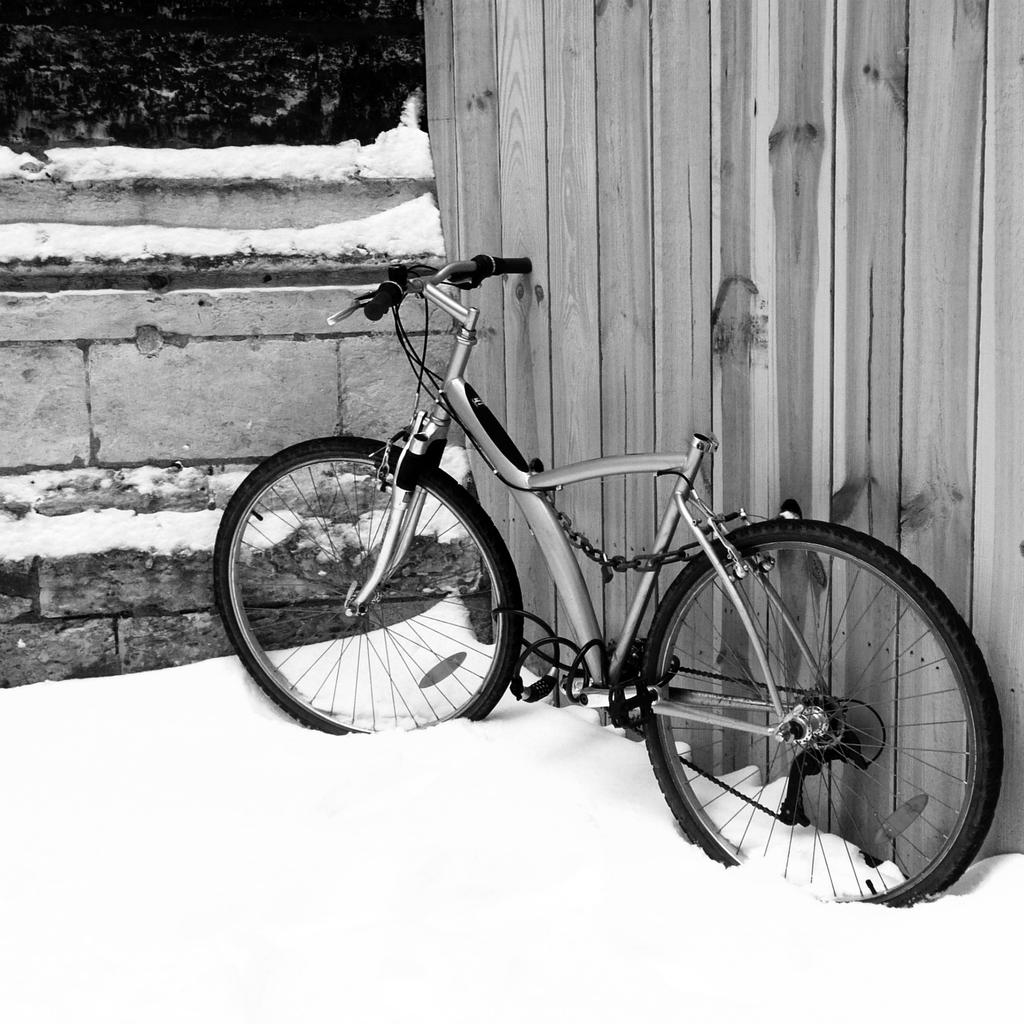What is the main object in the image? There is a bicycle in the image. What is the terrain like where the bicycle is located? The bicycle is on land covered with snow. What can be seen on the right side of the image? There is a wall on the right side of the image. What is visible in the top left corner of the image? There are trees on the left top of the image. What is the condition of the wall in front of the bicycle? There is a wall covered with snow before the bicycle. What type of science experiment is being conducted with the bicycle in the image? There is no indication of a science experiment in the image; it simply shows a bicycle on snow-covered land. How many chairs are visible in the image? There are no chairs present in the image. 